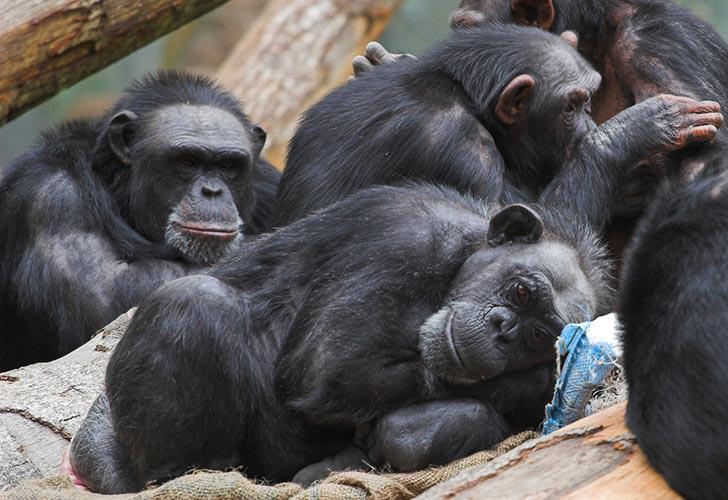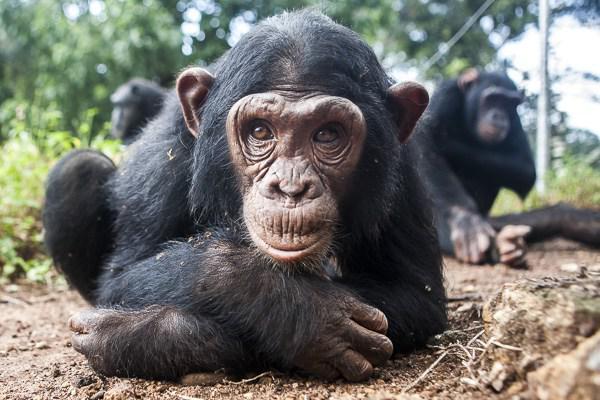The first image is the image on the left, the second image is the image on the right. For the images shown, is this caption "There is a baby monkey being held by its mother." true? Answer yes or no. No. The first image is the image on the left, the second image is the image on the right. For the images displayed, is the sentence "One chimp is holding another chimp." factually correct? Answer yes or no. No. 